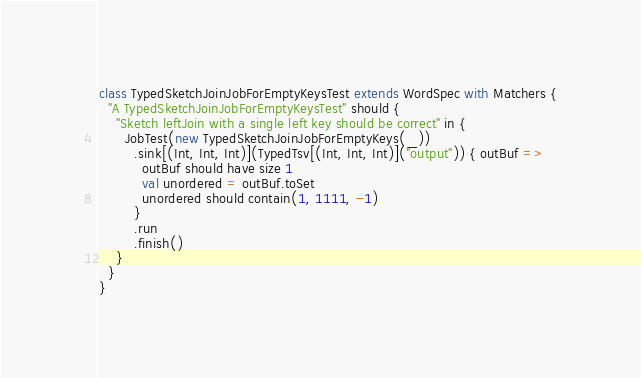Convert code to text. <code><loc_0><loc_0><loc_500><loc_500><_Scala_>class TypedSketchJoinJobForEmptyKeysTest extends WordSpec with Matchers {
  "A TypedSketchJoinJobForEmptyKeysTest" should {
    "Sketch leftJoin with a single left key should be correct" in {
      JobTest(new TypedSketchJoinJobForEmptyKeys(_))
        .sink[(Int, Int, Int)](TypedTsv[(Int, Int, Int)]("output")) { outBuf =>
          outBuf should have size 1
          val unordered = outBuf.toSet
          unordered should contain(1, 1111, -1)
        }
        .run
        .finish()
    }
  }
}
</code> 